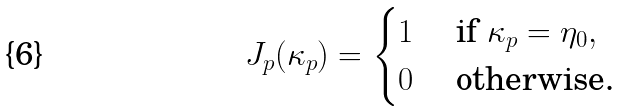Convert formula to latex. <formula><loc_0><loc_0><loc_500><loc_500>J _ { p } ( \kappa _ { p } ) = \begin{cases} 1 & \text { if } \kappa _ { p } = \eta _ { 0 } , \\ 0 & \text { otherwise.} \end{cases}</formula> 